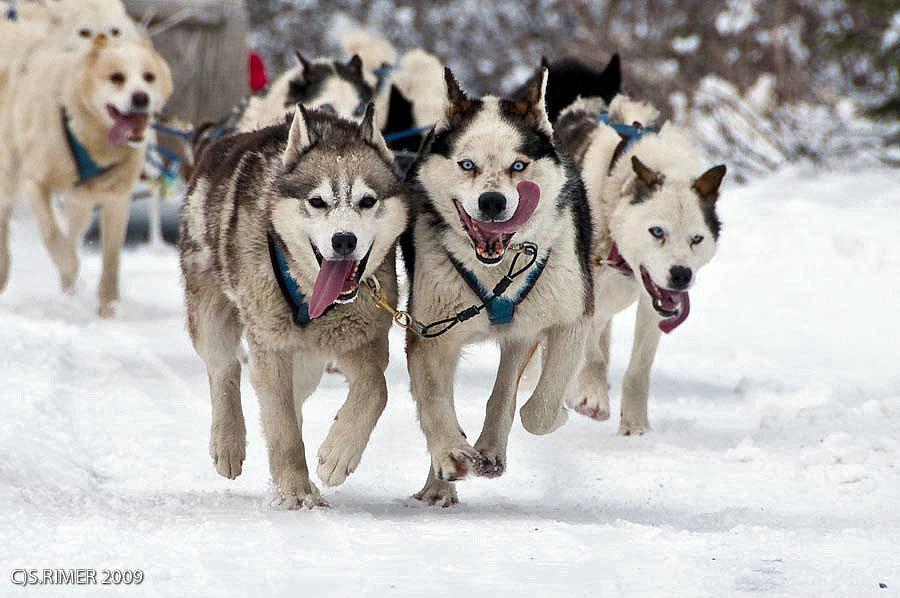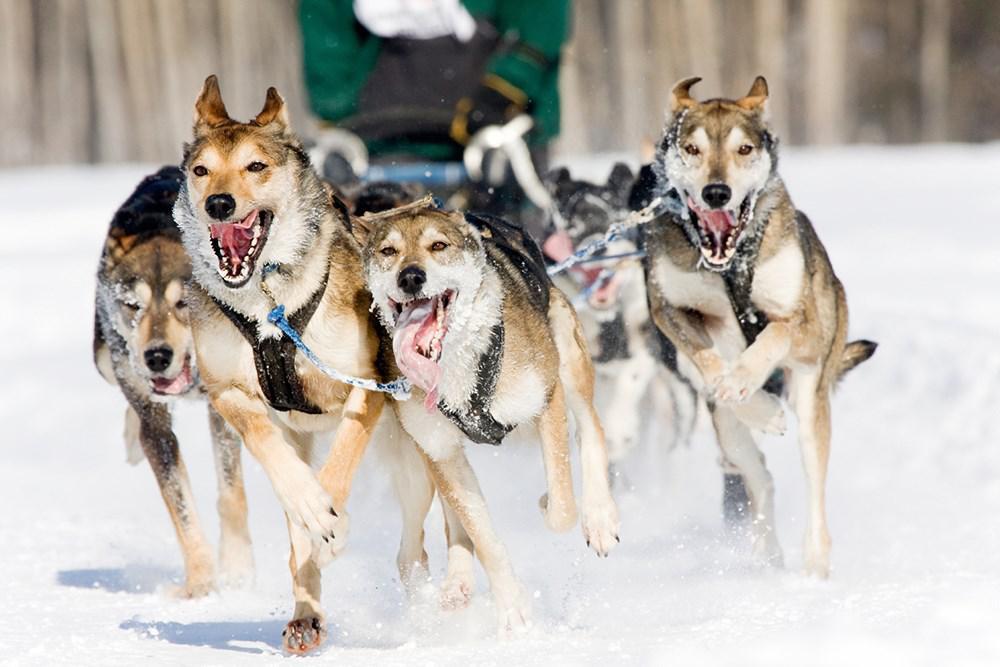The first image is the image on the left, the second image is the image on the right. Evaluate the accuracy of this statement regarding the images: "No lead sled dogs wear booties, and a sled driver is not visible in at least one image.". Is it true? Answer yes or no. Yes. The first image is the image on the left, the second image is the image on the right. Given the left and right images, does the statement "One image shows a dog sled team without a person." hold true? Answer yes or no. Yes. The first image is the image on the left, the second image is the image on the right. For the images shown, is this caption "There is no human visible in one of the images." true? Answer yes or no. Yes. 